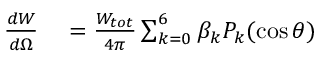<formula> <loc_0><loc_0><loc_500><loc_500>\begin{array} { r l } { \frac { d W } { d \Omega } } & = \frac { W _ { t o t } } { 4 \pi } \sum _ { k = 0 } ^ { 6 } \beta _ { k } P _ { k } ( \cos { \theta } ) } \end{array}</formula> 